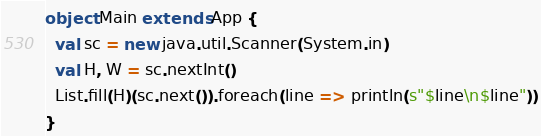Convert code to text. <code><loc_0><loc_0><loc_500><loc_500><_Scala_>object Main extends App {
  val sc = new java.util.Scanner(System.in)
  val H, W = sc.nextInt()
  List.fill(H)(sc.next()).foreach(line => println(s"$line\n$line"))
}
</code> 